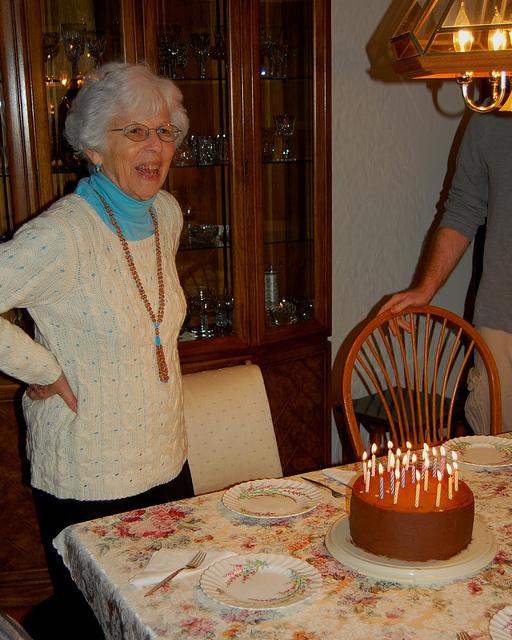What is on the woman's fork?
Write a very short answer. Nothing. Does the cake have more than 3 candles?
Short answer required. Yes. What holiday is represented in the tablecloth design?
Concise answer only. Birthday. Has the cake been cut?
Answer briefly. No. How many cakes are there?
Give a very brief answer. 1. Is this beautiful older woman having a birthday party?
Write a very short answer. Yes. Is she drinking beer with her meal?
Answer briefly. No. 